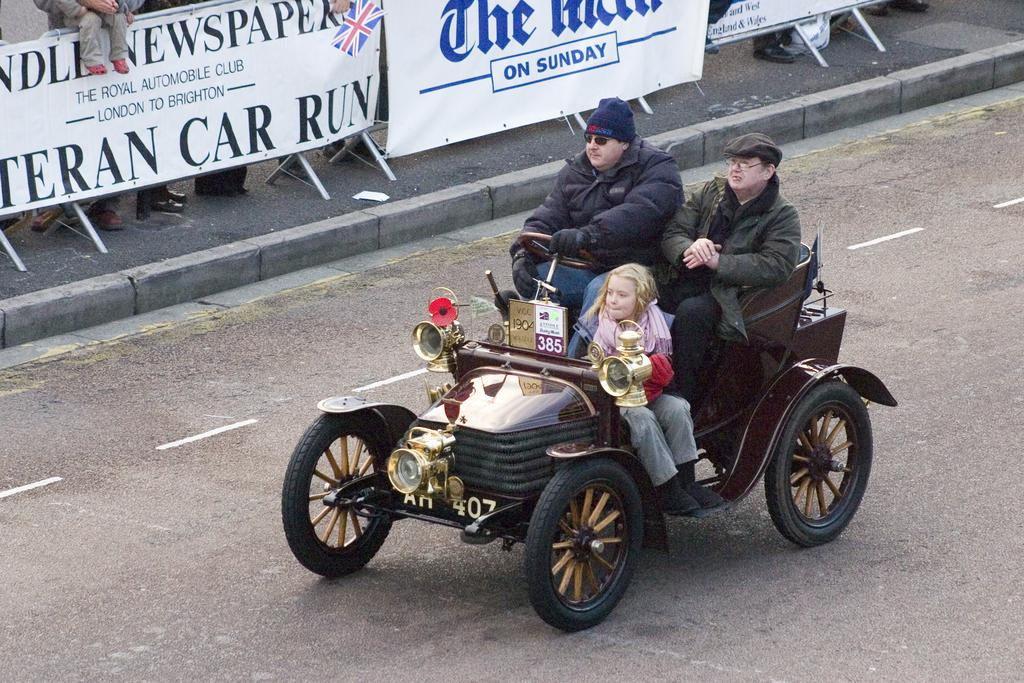How many people are present in the image? There are two men and a girl child in the image. What are the individuals in the image doing? They are traveling on a four-wheeler vehicle. Where is the vehicle located? The vehicle is on a road. What type of industrial structure can be seen in the background of the image? There is no industrial structure present in the image. What season is depicted in the image, considering the absence of snow or winter clothing? The season cannot be determined from the image, as there is no indication of snow or winter clothing. 